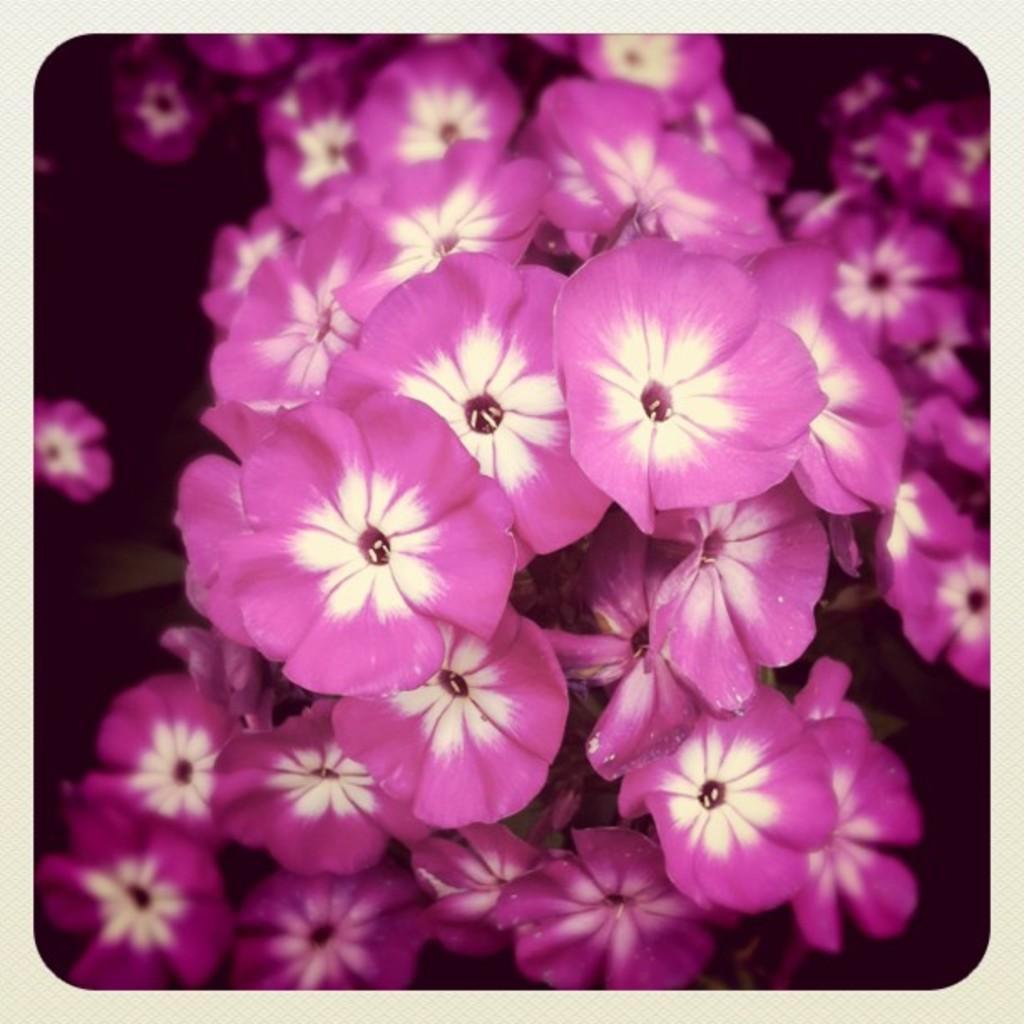Describe this image in one or two sentences. In this image I can see few purple and white color flowers and background is dark. 